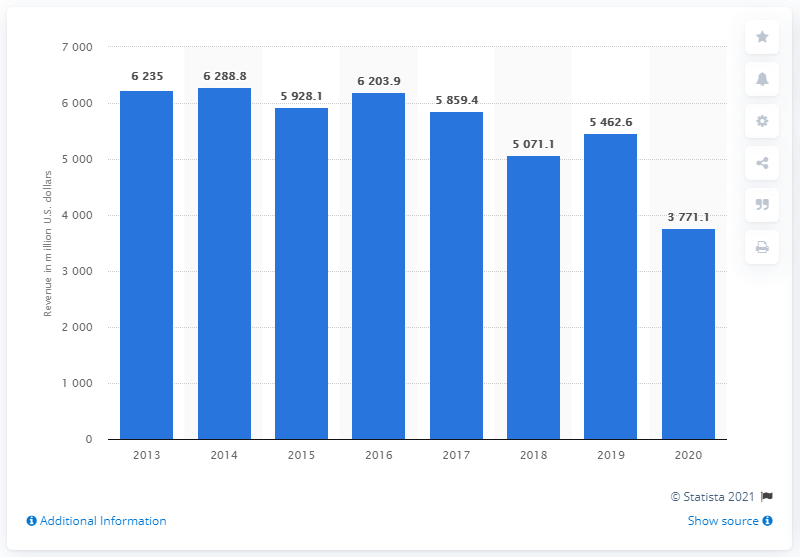Give some essential details in this illustration. In the fiscal year of 2013, Embraer was established. 